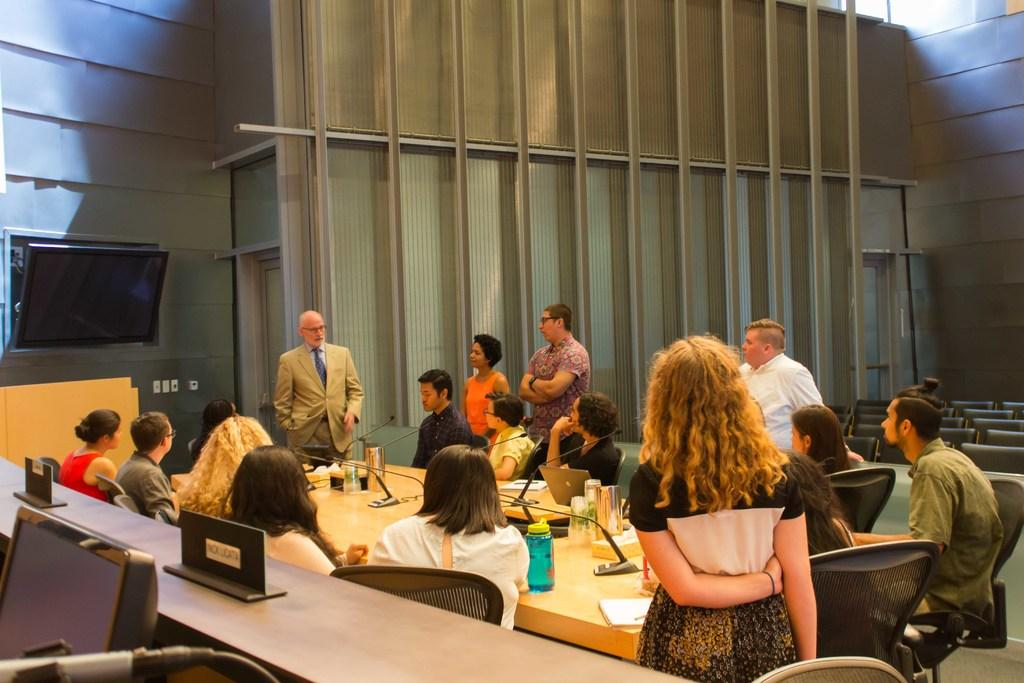How many people are in the image? There is a group of people in the image, but the exact number is not specified. What are the people in the image doing? Some people are sitting, and some are standing. What is on the table in the image? There are objects on the table. What type of furniture is present in the image? There are chairs in the image. What electronic device can be seen in the image? There is a television in the image. What is the title of the book that the person is reading in the image? There is no book or person reading in the image. How many bananas are on the table in the image? There are no bananas present in the image. 